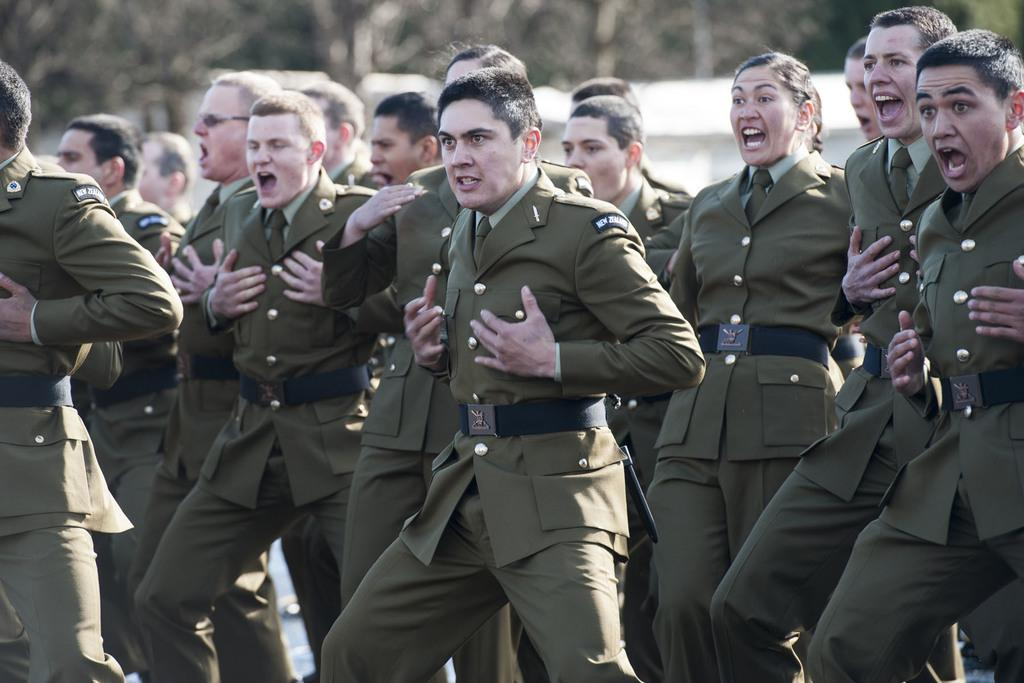What can be seen in the image? There are persons standing in the image. Can you describe the facial expressions of the persons? The persons have expressions on their faces. How would you describe the background of the image? The background of the image is blurry. How many thumbs can be seen on the persons in the image? There is no information about the number of thumbs visible on the persons in the image. Is the earth visible in the image? The earth is not visible in the image; it is a picture of persons standing with expressions on their faces. 